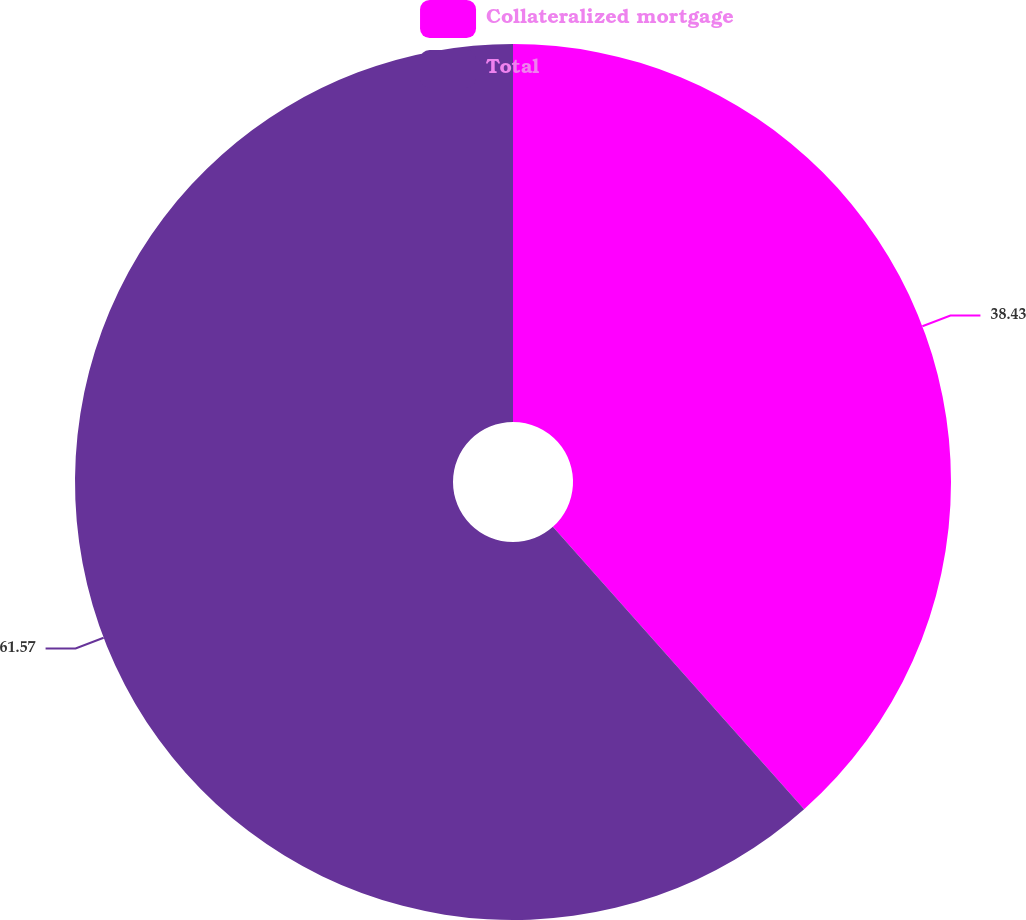Convert chart to OTSL. <chart><loc_0><loc_0><loc_500><loc_500><pie_chart><fcel>Collateralized mortgage<fcel>Total<nl><fcel>38.43%<fcel>61.57%<nl></chart> 